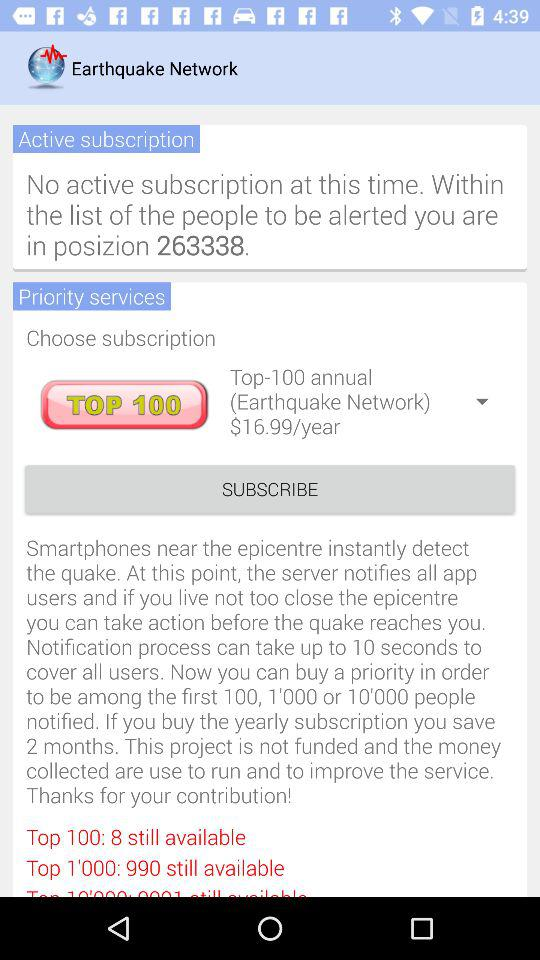How many months do you save if you buy a yearly subscription? On buying a yearly subscription, 2 months can be saved. 